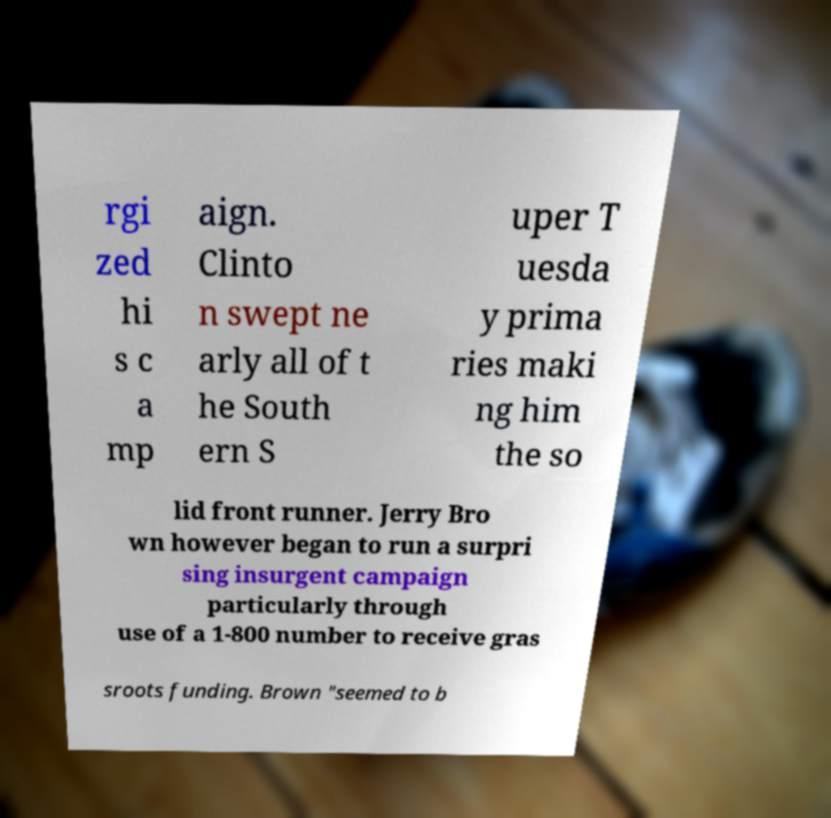Please identify and transcribe the text found in this image. rgi zed hi s c a mp aign. Clinto n swept ne arly all of t he South ern S uper T uesda y prima ries maki ng him the so lid front runner. Jerry Bro wn however began to run a surpri sing insurgent campaign particularly through use of a 1-800 number to receive gras sroots funding. Brown "seemed to b 